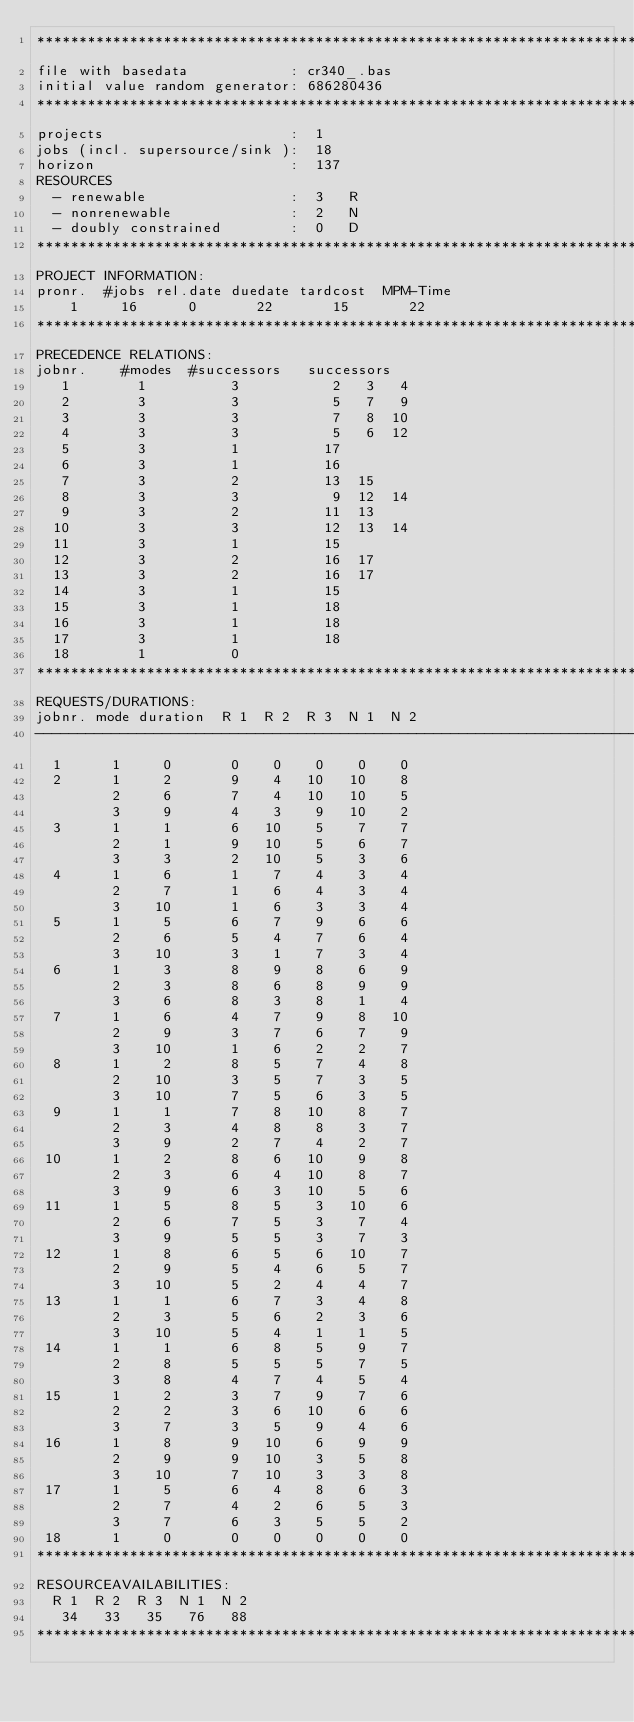<code> <loc_0><loc_0><loc_500><loc_500><_ObjectiveC_>************************************************************************
file with basedata            : cr340_.bas
initial value random generator: 686280436
************************************************************************
projects                      :  1
jobs (incl. supersource/sink ):  18
horizon                       :  137
RESOURCES
  - renewable                 :  3   R
  - nonrenewable              :  2   N
  - doubly constrained        :  0   D
************************************************************************
PROJECT INFORMATION:
pronr.  #jobs rel.date duedate tardcost  MPM-Time
    1     16      0       22       15       22
************************************************************************
PRECEDENCE RELATIONS:
jobnr.    #modes  #successors   successors
   1        1          3           2   3   4
   2        3          3           5   7   9
   3        3          3           7   8  10
   4        3          3           5   6  12
   5        3          1          17
   6        3          1          16
   7        3          2          13  15
   8        3          3           9  12  14
   9        3          2          11  13
  10        3          3          12  13  14
  11        3          1          15
  12        3          2          16  17
  13        3          2          16  17
  14        3          1          15
  15        3          1          18
  16        3          1          18
  17        3          1          18
  18        1          0        
************************************************************************
REQUESTS/DURATIONS:
jobnr. mode duration  R 1  R 2  R 3  N 1  N 2
------------------------------------------------------------------------
  1      1     0       0    0    0    0    0
  2      1     2       9    4   10   10    8
         2     6       7    4   10   10    5
         3     9       4    3    9   10    2
  3      1     1       6   10    5    7    7
         2     1       9   10    5    6    7
         3     3       2   10    5    3    6
  4      1     6       1    7    4    3    4
         2     7       1    6    4    3    4
         3    10       1    6    3    3    4
  5      1     5       6    7    9    6    6
         2     6       5    4    7    6    4
         3    10       3    1    7    3    4
  6      1     3       8    9    8    6    9
         2     3       8    6    8    9    9
         3     6       8    3    8    1    4
  7      1     6       4    7    9    8   10
         2     9       3    7    6    7    9
         3    10       1    6    2    2    7
  8      1     2       8    5    7    4    8
         2    10       3    5    7    3    5
         3    10       7    5    6    3    5
  9      1     1       7    8   10    8    7
         2     3       4    8    8    3    7
         3     9       2    7    4    2    7
 10      1     2       8    6   10    9    8
         2     3       6    4   10    8    7
         3     9       6    3   10    5    6
 11      1     5       8    5    3   10    6
         2     6       7    5    3    7    4
         3     9       5    5    3    7    3
 12      1     8       6    5    6   10    7
         2     9       5    4    6    5    7
         3    10       5    2    4    4    7
 13      1     1       6    7    3    4    8
         2     3       5    6    2    3    6
         3    10       5    4    1    1    5
 14      1     1       6    8    5    9    7
         2     8       5    5    5    7    5
         3     8       4    7    4    5    4
 15      1     2       3    7    9    7    6
         2     2       3    6   10    6    6
         3     7       3    5    9    4    6
 16      1     8       9   10    6    9    9
         2     9       9   10    3    5    8
         3    10       7   10    3    3    8
 17      1     5       6    4    8    6    3
         2     7       4    2    6    5    3
         3     7       6    3    5    5    2
 18      1     0       0    0    0    0    0
************************************************************************
RESOURCEAVAILABILITIES:
  R 1  R 2  R 3  N 1  N 2
   34   33   35   76   88
************************************************************************
</code> 